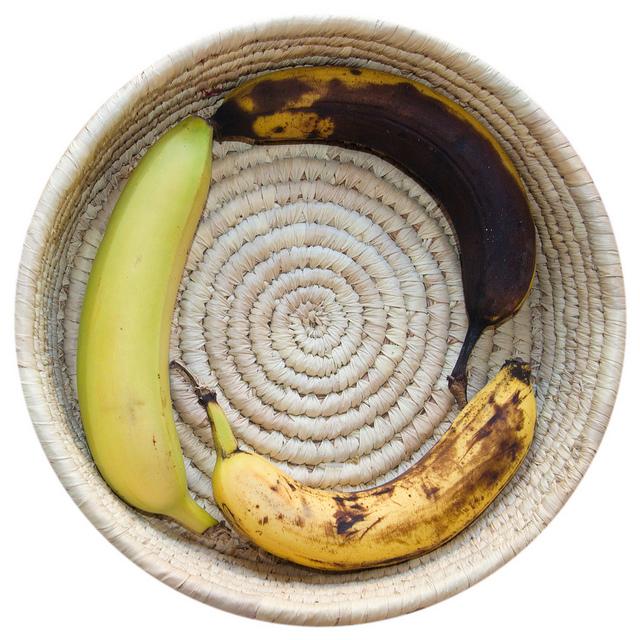Is this a handmade basket?
Short answer required. Yes. Does this picture illustrate the different stages of decomposition in a banana?
Short answer required. Yes. Are all of these edible?
Give a very brief answer. Yes. 